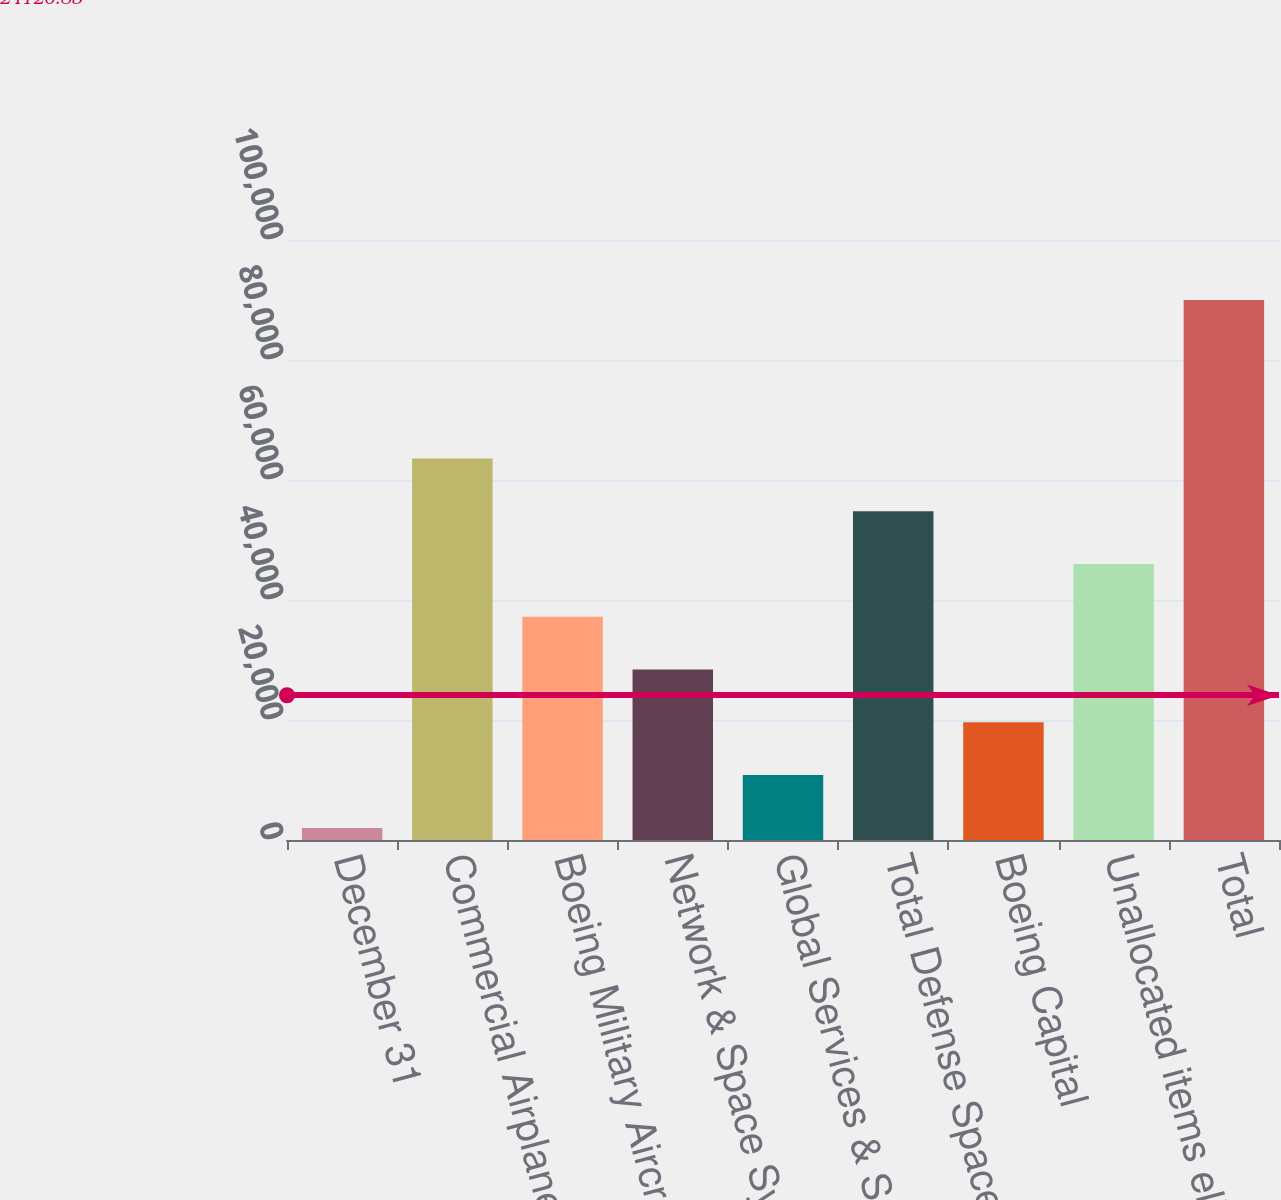Convert chart. <chart><loc_0><loc_0><loc_500><loc_500><bar_chart><fcel>December 31<fcel>Commercial Airplanes<fcel>Boeing Military Aircraft<fcel>Network & Space Systems<fcel>Global Services & Support<fcel>Total Defense Space & Security<fcel>Boeing Capital<fcel>Unallocated items eliminations<fcel>Total<nl><fcel>2016<fcel>63602.7<fcel>37208.4<fcel>28410.3<fcel>10814.1<fcel>54804.6<fcel>19612.2<fcel>46006.5<fcel>89997<nl></chart> 